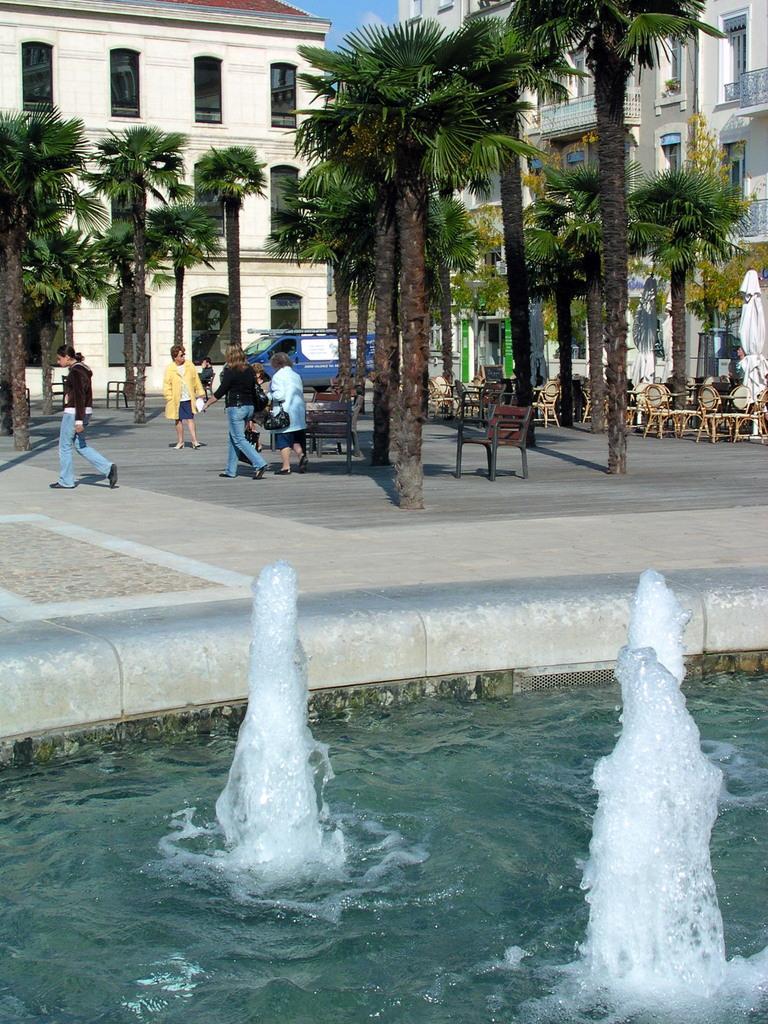Please provide a concise description of this image. In this picture there is a small water fountain in the front bottom side. Behind there are some coconut trees and a group of women walking. In the background there are some white color buildings and black windows. 